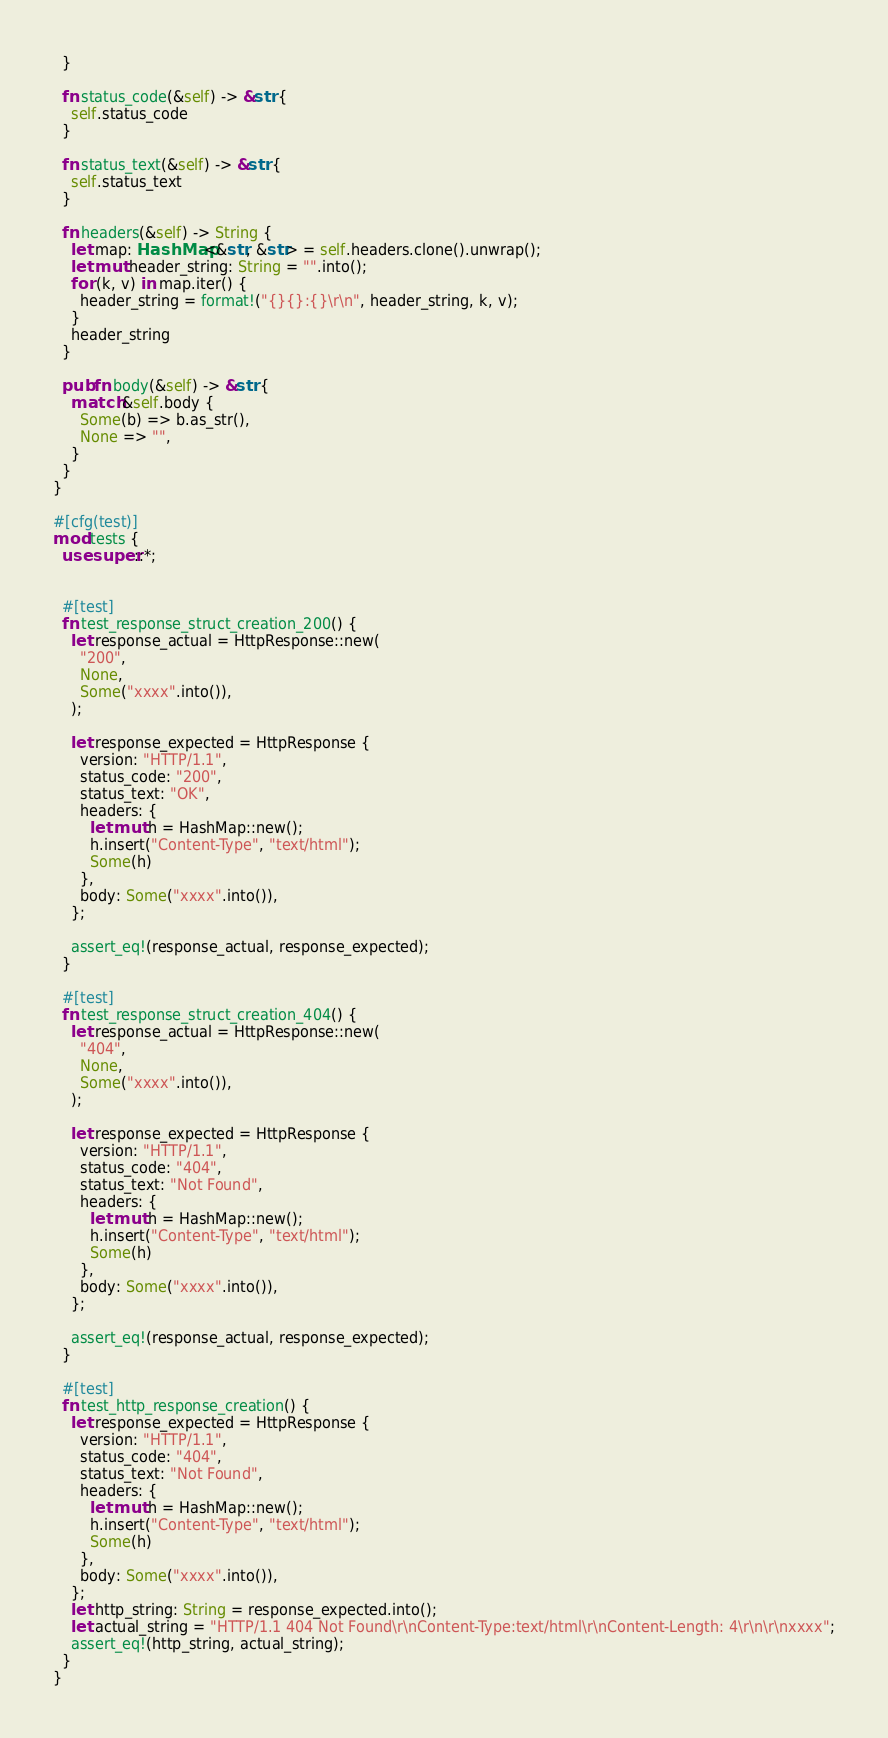<code> <loc_0><loc_0><loc_500><loc_500><_Rust_>  }

  fn status_code(&self) -> &str {
    self.status_code
  }

  fn status_text(&self) -> &str {
    self.status_text
  }

  fn headers(&self) -> String {
    let map: HashMap<&str, &str> = self.headers.clone().unwrap();
    let mut header_string: String = "".into();
    for (k, v) in map.iter() {
      header_string = format!("{}{}:{}\r\n", header_string, k, v);
    }
    header_string
  }

  pub fn body(&self) -> &str {
    match &self.body {
      Some(b) => b.as_str(),
      None => "",
    }
  }
}

#[cfg(test)]
mod tests {
  use super::*;


  #[test]
  fn test_response_struct_creation_200() {
    let response_actual = HttpResponse::new(
      "200",
      None,
      Some("xxxx".into()),
    );

    let response_expected = HttpResponse {
      version: "HTTP/1.1",
      status_code: "200",
      status_text: "OK",
      headers: {
        let mut h = HashMap::new();
        h.insert("Content-Type", "text/html");
        Some(h)
      },
      body: Some("xxxx".into()),
    };

    assert_eq!(response_actual, response_expected);
  }

  #[test]
  fn test_response_struct_creation_404() {
    let response_actual = HttpResponse::new(
      "404",
      None,
      Some("xxxx".into()),
    );

    let response_expected = HttpResponse {
      version: "HTTP/1.1",
      status_code: "404",
      status_text: "Not Found",
      headers: {
        let mut h = HashMap::new();
        h.insert("Content-Type", "text/html");
        Some(h)
      },
      body: Some("xxxx".into()),
    };

    assert_eq!(response_actual, response_expected);
  }

  #[test]
  fn test_http_response_creation() {
    let response_expected = HttpResponse {
      version: "HTTP/1.1",
      status_code: "404",
      status_text: "Not Found",
      headers: {
        let mut h = HashMap::new();
        h.insert("Content-Type", "text/html");
        Some(h)
      },
      body: Some("xxxx".into()),
    };
    let http_string: String = response_expected.into();
    let actual_string = "HTTP/1.1 404 Not Found\r\nContent-Type:text/html\r\nContent-Length: 4\r\n\r\nxxxx";
    assert_eq!(http_string, actual_string);
  }
}</code> 